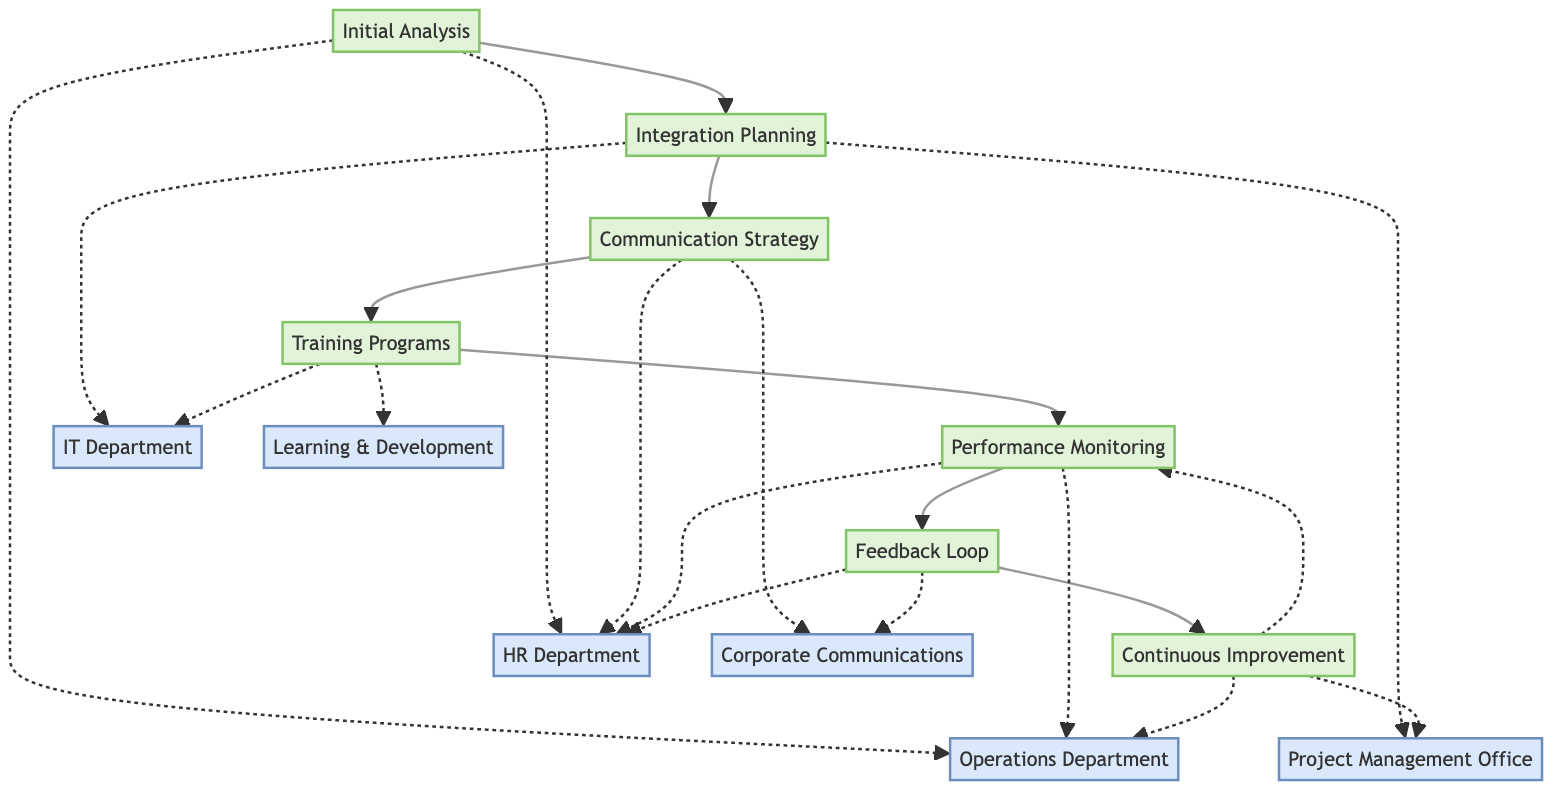What is the first step in the workflow? The first step in the workflow is "Initial Analysis." It is located at the top of the diagram and is the starting point for the subsequent processes.
Answer: Initial Analysis How many nodes are there in total? By counting the various elements represented, we identify seven distinct process nodes outlined in the diagram, each representing a different workflow step.
Answer: 7 Which department is associated with "Performance Monitoring"? The "Performance Monitoring" process is associated with both the "Operations Department" and "HR Department," as indicated by the connections shown in the diagram.
Answer: Operations Department, HR Department What follows "Training Programs" in the workflow? After "Training Programs," the next step in the workflow is "Performance Monitoring," which is indicated by the directed arrow leading from Training Programs to Performance Monitoring.
Answer: Performance Monitoring Which two departments are involved in "Feedback Loop"? The "Feedback Loop" is associated with both "Corporate Communications" and "HR Department," as shown by the dashed lines connecting these entities to the process.
Answer: Corporate Communications, HR Department What process leads to "Continuous Improvement"? "Continuous Improvement" is preceded by the "Feedback Loop" process, as indicated by the direct connection flowing from Feedback Loop to Continuous Improvement.
Answer: Feedback Loop Which step is focused on staff training? The step that is focused on staff training is "Training Programs." It is explicitly described in the diagram as implementing training for staff on new workflows and tools.
Answer: Training Programs How does feedback influence the workflow? Feedback collected through the "Feedback Loop" plays a crucial role in fostering "Continuous Improvement," allowing for ongoing adjustments based on staff input which is evident from the connection between these two processes.
Answer: Continuous Improvement What is the main purpose of "Integration Planning"? The main purpose of "Integration Planning" is to design new workflows that combine best practices from both companies, as noted in its description.
Answer: Design new workflows 